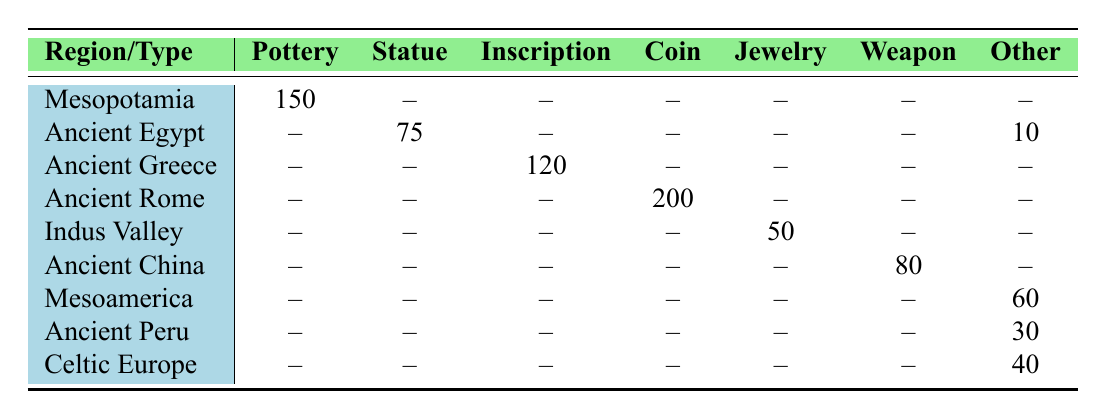What is the count of Pottery artifacts in Mesopotamia? The table shows that there are 150 Pottery artifacts specifically listed for Mesopotamia in the corresponding row.
Answer: 150 How many Coin artifacts are there in Ancient Rome? The corresponding row for Ancient Rome indicates there are 200 Coin artifacts.
Answer: 200 Are there more inscriptions in Ancient Greece than Jewelry in the Indus Valley? The table shows 120 inscriptions in Ancient Greece and 50 Jewelry artifacts in the Indus Valley. Since 120 > 50, the answer is yes.
Answer: Yes Which region has the highest count of artifacts, and what is that count? To find the highest count, we need to compare the counts across all artifacts: Mesopotamia (150), Ancient Egypt (85 total), Ancient Greece (120), Ancient Rome (200), Indus Valley (50), Ancient China (80), Mesoamerica (60), Ancient Peru (30), Celtic Europe (40). The highest count is 200 in Ancient Rome.
Answer: Ancient Rome, 200 What is the total count of architectural artifacts across all regions? The table shows 10 architectural artifacts located only in Ancient Egypt. Since this is the only entry for this category, the total is simply 10.
Answer: 10 Is there a region that does not have any Pottery artifacts listed? Checking the Pottery artifacts count across the regions, the regions listed are Ancient Egypt, Ancient Greece, Ancient Rome, Indus Valley, Ancient China, Mesoamerica, Ancient Peru, and Celtic Europe. The only region with an explicitly recorded pottery count is Mesopotamia, indicating that all other regions do not have Pottery artifacts listed.
Answer: Yes What is the sum of counts of Religious Artifacts and Jewelry? The count of Religious Artifacts from Celtic Europe is 40, and Jewelry from the Indus Valley is 50. Summing these gives: 40 + 50 = 90.
Answer: 90 Which region has the largest number of different types of artifacts listed? To determine this, we assess the presence of artifacts in each region. Mesopotamia has 1, Ancient Egypt has 2, Ancient Greece has 1, Ancient Rome has 1, Indus Valley has 1, Ancient China has 1, Mesoamerica has 1, Ancient Peru has 1, and Celtic Europe has 1, indicating Ancient Egypt has the largest number of different types (2).
Answer: Ancient Egypt 